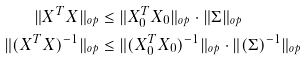<formula> <loc_0><loc_0><loc_500><loc_500>\| X ^ { T } X \| _ { o p } & \leq \| X _ { 0 } ^ { T } X _ { 0 } \| _ { o p } \cdot \| \Sigma \| _ { o p } \\ \| ( X ^ { T } X ) ^ { - 1 } \| _ { o p } & \leq \| ( X _ { 0 } ^ { T } X _ { 0 } ) ^ { - 1 } \| _ { o p } \cdot \| ( \Sigma ) ^ { - 1 } \| _ { o p }</formula> 